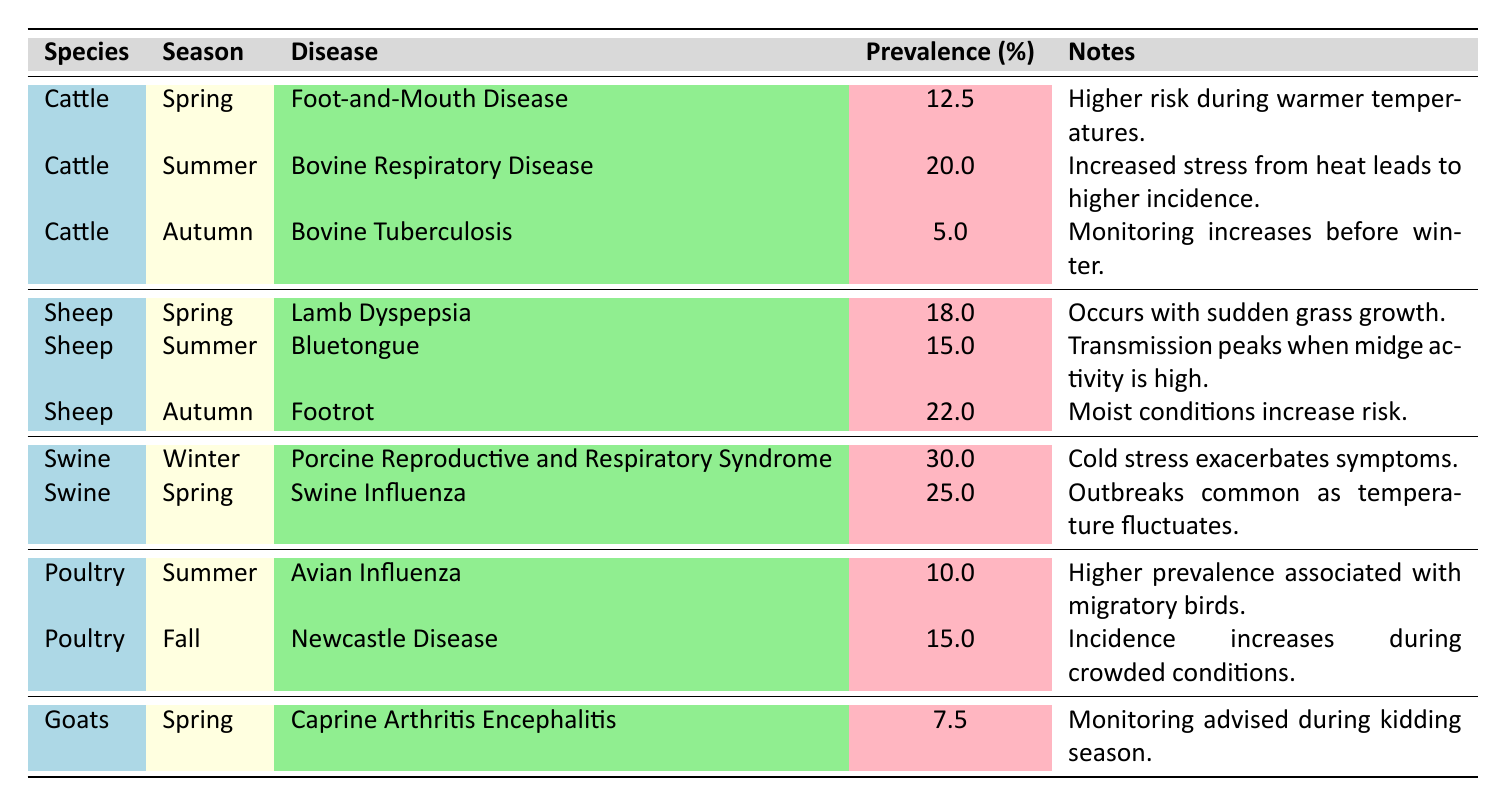What is the disease with the highest prevalence in swine? Based on the table, the disease with the highest prevalence in swine is Porcine Reproductive and Respiratory Syndrome, which has a prevalence of 30%.
Answer: Porcine Reproductive and Respiratory Syndrome How does the prevalence of Bovine Tuberculosis compare to that of Foot-and-Mouth Disease in cattle? The prevalence of Bovine Tuberculosis is 5.0% while Foot-and-Mouth Disease is 12.5%. Comparing these two values shows that Foot-and-Mouth Disease has a higher prevalence than Bovine Tuberculosis.
Answer: Foot-and-Mouth Disease has a higher prevalence What is the average prevalence percentage of diseases affecting sheep in autumn? The only disease affecting sheep in autumn is Footrot, with a prevalence of 22.0%. Since there is only one value, the average prevalence is the same as the prevalence of that disease.
Answer: 22.0% Is the prevalence of Bluetongue higher in summer or Footrot in autumn? Bluetongue has a prevalence of 15.0% in summer, while Footrot has a prevalence of 22.0% in autumn. Comparing these two numbers shows that Footrot has a higher prevalence than Bluetongue.
Answer: Footrot has a higher prevalence In which season do goats have the lowest disease prevalence? From the table, goats have the disease Caprine Arthritis Encephalitis in spring with a prevalence of 7.5%. This is the only disease listed for goats, thus it is their only point of reference. Since we only have one value, we conclude that this is their lowest prevalence.
Answer: Spring Which species experiences the highest disease prevalence overall? To determine this, we can look for the highest prevalence percentage across all species. In the table, Swine with Porcine Reproductive and Respiratory Syndrome has the highest prevalence of 30%, which is greater than any disease prevalence of other species.
Answer: Swine How many diseases have a prevalence of over 20% in autumn? The table shows that only Footrot in sheep has a prevalence greater than 20% in autumn with 22.0%. Autumn diseases for cattle and goats have prevalence percentages of 5.0% and 7.5% respectively. Therefore, there is only one such disease.
Answer: One disease Are there any diseases in spring with a prevalence above 20%? By examining the table, we see that in spring, diseases affecting cattle and swine have prevalences of 12.5% and 25.0% respectively, while sheep have 18.0% and goats have 7.5%. Since none of these values exceed 20%, there are no diseases in spring above this threshold.
Answer: No What is the total prevalence percentage of diseases affecting cattle during all seasons? The total prevalence for cattle across the seasons can be computed as follows: 12.5% (Spring) + 20.0% (Summer) + 5.0% (Autumn) = 37.5%. By summing these three values, we find the total for cattle.
Answer: 37.5% 